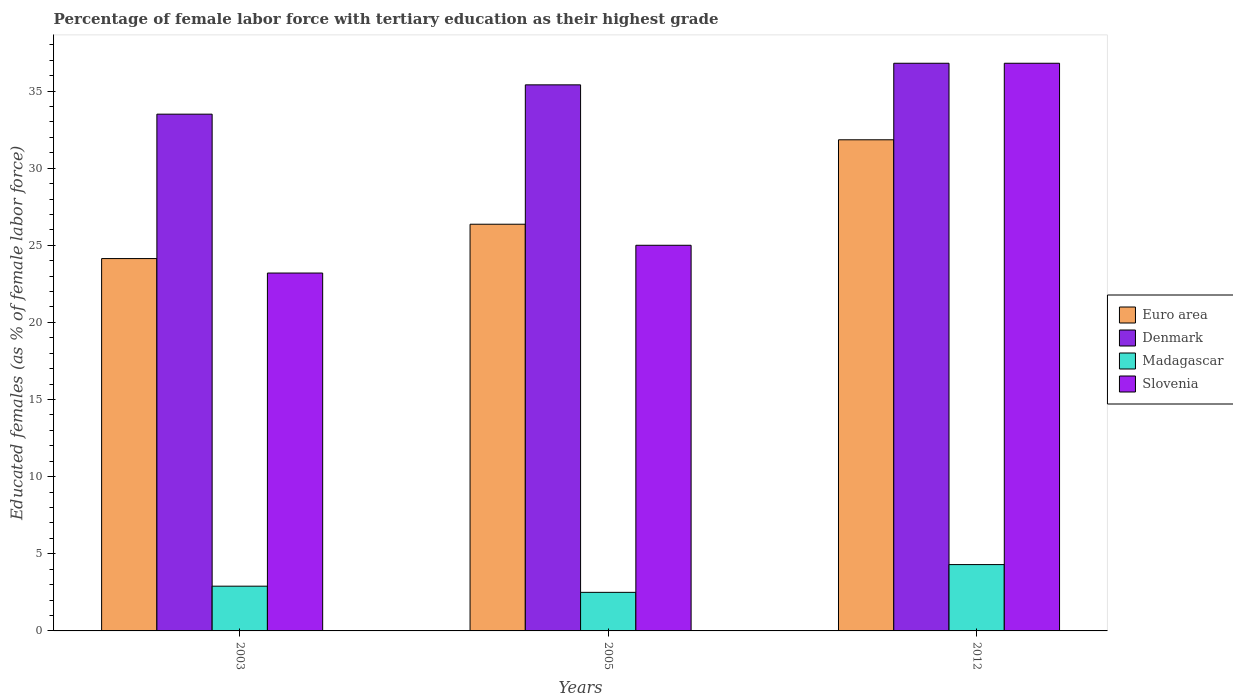How many different coloured bars are there?
Offer a terse response. 4. How many bars are there on the 2nd tick from the right?
Make the answer very short. 4. What is the label of the 1st group of bars from the left?
Offer a very short reply. 2003. What is the percentage of female labor force with tertiary education in Madagascar in 2012?
Keep it short and to the point. 4.3. Across all years, what is the maximum percentage of female labor force with tertiary education in Euro area?
Your answer should be compact. 31.84. Across all years, what is the minimum percentage of female labor force with tertiary education in Slovenia?
Ensure brevity in your answer.  23.2. In which year was the percentage of female labor force with tertiary education in Euro area minimum?
Ensure brevity in your answer.  2003. What is the total percentage of female labor force with tertiary education in Madagascar in the graph?
Offer a terse response. 9.7. What is the difference between the percentage of female labor force with tertiary education in Madagascar in 2003 and that in 2005?
Provide a succinct answer. 0.4. What is the difference between the percentage of female labor force with tertiary education in Slovenia in 2003 and the percentage of female labor force with tertiary education in Denmark in 2005?
Offer a terse response. -12.2. What is the average percentage of female labor force with tertiary education in Euro area per year?
Provide a succinct answer. 27.45. In the year 2012, what is the difference between the percentage of female labor force with tertiary education in Euro area and percentage of female labor force with tertiary education in Denmark?
Make the answer very short. -4.96. In how many years, is the percentage of female labor force with tertiary education in Euro area greater than 12 %?
Keep it short and to the point. 3. What is the ratio of the percentage of female labor force with tertiary education in Euro area in 2003 to that in 2012?
Ensure brevity in your answer.  0.76. Is the difference between the percentage of female labor force with tertiary education in Euro area in 2005 and 2012 greater than the difference between the percentage of female labor force with tertiary education in Denmark in 2005 and 2012?
Provide a succinct answer. No. What is the difference between the highest and the second highest percentage of female labor force with tertiary education in Slovenia?
Your answer should be very brief. 11.8. What is the difference between the highest and the lowest percentage of female labor force with tertiary education in Madagascar?
Make the answer very short. 1.8. In how many years, is the percentage of female labor force with tertiary education in Euro area greater than the average percentage of female labor force with tertiary education in Euro area taken over all years?
Ensure brevity in your answer.  1. Is the sum of the percentage of female labor force with tertiary education in Euro area in 2005 and 2012 greater than the maximum percentage of female labor force with tertiary education in Madagascar across all years?
Your answer should be compact. Yes. What does the 1st bar from the right in 2012 represents?
Make the answer very short. Slovenia. Is it the case that in every year, the sum of the percentage of female labor force with tertiary education in Denmark and percentage of female labor force with tertiary education in Slovenia is greater than the percentage of female labor force with tertiary education in Madagascar?
Your answer should be very brief. Yes. How many bars are there?
Provide a short and direct response. 12. Are all the bars in the graph horizontal?
Give a very brief answer. No. How many years are there in the graph?
Your response must be concise. 3. Does the graph contain grids?
Keep it short and to the point. No. What is the title of the graph?
Your answer should be very brief. Percentage of female labor force with tertiary education as their highest grade. Does "Czech Republic" appear as one of the legend labels in the graph?
Offer a terse response. No. What is the label or title of the Y-axis?
Your response must be concise. Educated females (as % of female labor force). What is the Educated females (as % of female labor force) of Euro area in 2003?
Provide a short and direct response. 24.14. What is the Educated females (as % of female labor force) in Denmark in 2003?
Provide a short and direct response. 33.5. What is the Educated females (as % of female labor force) of Madagascar in 2003?
Provide a short and direct response. 2.9. What is the Educated females (as % of female labor force) in Slovenia in 2003?
Provide a short and direct response. 23.2. What is the Educated females (as % of female labor force) of Euro area in 2005?
Your answer should be very brief. 26.36. What is the Educated females (as % of female labor force) of Denmark in 2005?
Make the answer very short. 35.4. What is the Educated females (as % of female labor force) of Euro area in 2012?
Your answer should be very brief. 31.84. What is the Educated females (as % of female labor force) of Denmark in 2012?
Ensure brevity in your answer.  36.8. What is the Educated females (as % of female labor force) in Madagascar in 2012?
Ensure brevity in your answer.  4.3. What is the Educated females (as % of female labor force) of Slovenia in 2012?
Keep it short and to the point. 36.8. Across all years, what is the maximum Educated females (as % of female labor force) of Euro area?
Make the answer very short. 31.84. Across all years, what is the maximum Educated females (as % of female labor force) in Denmark?
Give a very brief answer. 36.8. Across all years, what is the maximum Educated females (as % of female labor force) of Madagascar?
Keep it short and to the point. 4.3. Across all years, what is the maximum Educated females (as % of female labor force) of Slovenia?
Offer a very short reply. 36.8. Across all years, what is the minimum Educated females (as % of female labor force) of Euro area?
Ensure brevity in your answer.  24.14. Across all years, what is the minimum Educated females (as % of female labor force) of Denmark?
Give a very brief answer. 33.5. Across all years, what is the minimum Educated females (as % of female labor force) of Slovenia?
Ensure brevity in your answer.  23.2. What is the total Educated females (as % of female labor force) of Euro area in the graph?
Give a very brief answer. 82.34. What is the total Educated females (as % of female labor force) of Denmark in the graph?
Keep it short and to the point. 105.7. What is the total Educated females (as % of female labor force) in Madagascar in the graph?
Provide a succinct answer. 9.7. What is the difference between the Educated females (as % of female labor force) of Euro area in 2003 and that in 2005?
Your answer should be compact. -2.23. What is the difference between the Educated females (as % of female labor force) in Denmark in 2003 and that in 2005?
Keep it short and to the point. -1.9. What is the difference between the Educated females (as % of female labor force) of Madagascar in 2003 and that in 2005?
Keep it short and to the point. 0.4. What is the difference between the Educated females (as % of female labor force) of Slovenia in 2003 and that in 2005?
Offer a very short reply. -1.8. What is the difference between the Educated females (as % of female labor force) in Euro area in 2003 and that in 2012?
Give a very brief answer. -7.7. What is the difference between the Educated females (as % of female labor force) of Denmark in 2003 and that in 2012?
Offer a terse response. -3.3. What is the difference between the Educated females (as % of female labor force) of Madagascar in 2003 and that in 2012?
Your answer should be compact. -1.4. What is the difference between the Educated females (as % of female labor force) in Euro area in 2005 and that in 2012?
Your answer should be compact. -5.47. What is the difference between the Educated females (as % of female labor force) in Madagascar in 2005 and that in 2012?
Provide a succinct answer. -1.8. What is the difference between the Educated females (as % of female labor force) of Euro area in 2003 and the Educated females (as % of female labor force) of Denmark in 2005?
Your response must be concise. -11.26. What is the difference between the Educated females (as % of female labor force) in Euro area in 2003 and the Educated females (as % of female labor force) in Madagascar in 2005?
Provide a succinct answer. 21.64. What is the difference between the Educated females (as % of female labor force) in Euro area in 2003 and the Educated females (as % of female labor force) in Slovenia in 2005?
Keep it short and to the point. -0.86. What is the difference between the Educated females (as % of female labor force) of Denmark in 2003 and the Educated females (as % of female labor force) of Madagascar in 2005?
Your answer should be compact. 31. What is the difference between the Educated females (as % of female labor force) in Denmark in 2003 and the Educated females (as % of female labor force) in Slovenia in 2005?
Provide a short and direct response. 8.5. What is the difference between the Educated females (as % of female labor force) in Madagascar in 2003 and the Educated females (as % of female labor force) in Slovenia in 2005?
Provide a short and direct response. -22.1. What is the difference between the Educated females (as % of female labor force) in Euro area in 2003 and the Educated females (as % of female labor force) in Denmark in 2012?
Offer a very short reply. -12.66. What is the difference between the Educated females (as % of female labor force) of Euro area in 2003 and the Educated females (as % of female labor force) of Madagascar in 2012?
Provide a succinct answer. 19.84. What is the difference between the Educated females (as % of female labor force) of Euro area in 2003 and the Educated females (as % of female labor force) of Slovenia in 2012?
Keep it short and to the point. -12.66. What is the difference between the Educated females (as % of female labor force) of Denmark in 2003 and the Educated females (as % of female labor force) of Madagascar in 2012?
Offer a terse response. 29.2. What is the difference between the Educated females (as % of female labor force) in Madagascar in 2003 and the Educated females (as % of female labor force) in Slovenia in 2012?
Your response must be concise. -33.9. What is the difference between the Educated females (as % of female labor force) of Euro area in 2005 and the Educated females (as % of female labor force) of Denmark in 2012?
Give a very brief answer. -10.44. What is the difference between the Educated females (as % of female labor force) of Euro area in 2005 and the Educated females (as % of female labor force) of Madagascar in 2012?
Your answer should be compact. 22.06. What is the difference between the Educated females (as % of female labor force) of Euro area in 2005 and the Educated females (as % of female labor force) of Slovenia in 2012?
Your answer should be compact. -10.44. What is the difference between the Educated females (as % of female labor force) of Denmark in 2005 and the Educated females (as % of female labor force) of Madagascar in 2012?
Your answer should be very brief. 31.1. What is the difference between the Educated females (as % of female labor force) of Denmark in 2005 and the Educated females (as % of female labor force) of Slovenia in 2012?
Provide a short and direct response. -1.4. What is the difference between the Educated females (as % of female labor force) in Madagascar in 2005 and the Educated females (as % of female labor force) in Slovenia in 2012?
Your answer should be compact. -34.3. What is the average Educated females (as % of female labor force) of Euro area per year?
Your answer should be very brief. 27.45. What is the average Educated females (as % of female labor force) of Denmark per year?
Give a very brief answer. 35.23. What is the average Educated females (as % of female labor force) of Madagascar per year?
Your response must be concise. 3.23. What is the average Educated females (as % of female labor force) of Slovenia per year?
Offer a very short reply. 28.33. In the year 2003, what is the difference between the Educated females (as % of female labor force) of Euro area and Educated females (as % of female labor force) of Denmark?
Offer a terse response. -9.36. In the year 2003, what is the difference between the Educated females (as % of female labor force) in Euro area and Educated females (as % of female labor force) in Madagascar?
Ensure brevity in your answer.  21.24. In the year 2003, what is the difference between the Educated females (as % of female labor force) of Euro area and Educated females (as % of female labor force) of Slovenia?
Offer a very short reply. 0.94. In the year 2003, what is the difference between the Educated females (as % of female labor force) in Denmark and Educated females (as % of female labor force) in Madagascar?
Provide a succinct answer. 30.6. In the year 2003, what is the difference between the Educated females (as % of female labor force) in Denmark and Educated females (as % of female labor force) in Slovenia?
Make the answer very short. 10.3. In the year 2003, what is the difference between the Educated females (as % of female labor force) of Madagascar and Educated females (as % of female labor force) of Slovenia?
Give a very brief answer. -20.3. In the year 2005, what is the difference between the Educated females (as % of female labor force) in Euro area and Educated females (as % of female labor force) in Denmark?
Give a very brief answer. -9.04. In the year 2005, what is the difference between the Educated females (as % of female labor force) in Euro area and Educated females (as % of female labor force) in Madagascar?
Keep it short and to the point. 23.86. In the year 2005, what is the difference between the Educated females (as % of female labor force) of Euro area and Educated females (as % of female labor force) of Slovenia?
Your response must be concise. 1.36. In the year 2005, what is the difference between the Educated females (as % of female labor force) of Denmark and Educated females (as % of female labor force) of Madagascar?
Offer a very short reply. 32.9. In the year 2005, what is the difference between the Educated females (as % of female labor force) of Madagascar and Educated females (as % of female labor force) of Slovenia?
Offer a very short reply. -22.5. In the year 2012, what is the difference between the Educated females (as % of female labor force) of Euro area and Educated females (as % of female labor force) of Denmark?
Make the answer very short. -4.96. In the year 2012, what is the difference between the Educated females (as % of female labor force) in Euro area and Educated females (as % of female labor force) in Madagascar?
Give a very brief answer. 27.54. In the year 2012, what is the difference between the Educated females (as % of female labor force) in Euro area and Educated females (as % of female labor force) in Slovenia?
Your answer should be compact. -4.96. In the year 2012, what is the difference between the Educated females (as % of female labor force) of Denmark and Educated females (as % of female labor force) of Madagascar?
Provide a short and direct response. 32.5. In the year 2012, what is the difference between the Educated females (as % of female labor force) in Denmark and Educated females (as % of female labor force) in Slovenia?
Offer a very short reply. 0. In the year 2012, what is the difference between the Educated females (as % of female labor force) of Madagascar and Educated females (as % of female labor force) of Slovenia?
Offer a very short reply. -32.5. What is the ratio of the Educated females (as % of female labor force) of Euro area in 2003 to that in 2005?
Give a very brief answer. 0.92. What is the ratio of the Educated females (as % of female labor force) in Denmark in 2003 to that in 2005?
Provide a succinct answer. 0.95. What is the ratio of the Educated females (as % of female labor force) in Madagascar in 2003 to that in 2005?
Provide a succinct answer. 1.16. What is the ratio of the Educated females (as % of female labor force) of Slovenia in 2003 to that in 2005?
Offer a terse response. 0.93. What is the ratio of the Educated females (as % of female labor force) of Euro area in 2003 to that in 2012?
Give a very brief answer. 0.76. What is the ratio of the Educated females (as % of female labor force) in Denmark in 2003 to that in 2012?
Provide a short and direct response. 0.91. What is the ratio of the Educated females (as % of female labor force) of Madagascar in 2003 to that in 2012?
Give a very brief answer. 0.67. What is the ratio of the Educated females (as % of female labor force) of Slovenia in 2003 to that in 2012?
Offer a terse response. 0.63. What is the ratio of the Educated females (as % of female labor force) in Euro area in 2005 to that in 2012?
Offer a terse response. 0.83. What is the ratio of the Educated females (as % of female labor force) of Denmark in 2005 to that in 2012?
Your answer should be compact. 0.96. What is the ratio of the Educated females (as % of female labor force) in Madagascar in 2005 to that in 2012?
Your answer should be compact. 0.58. What is the ratio of the Educated females (as % of female labor force) of Slovenia in 2005 to that in 2012?
Make the answer very short. 0.68. What is the difference between the highest and the second highest Educated females (as % of female labor force) of Euro area?
Offer a very short reply. 5.47. What is the difference between the highest and the second highest Educated females (as % of female labor force) in Slovenia?
Keep it short and to the point. 11.8. What is the difference between the highest and the lowest Educated females (as % of female labor force) in Euro area?
Keep it short and to the point. 7.7. 